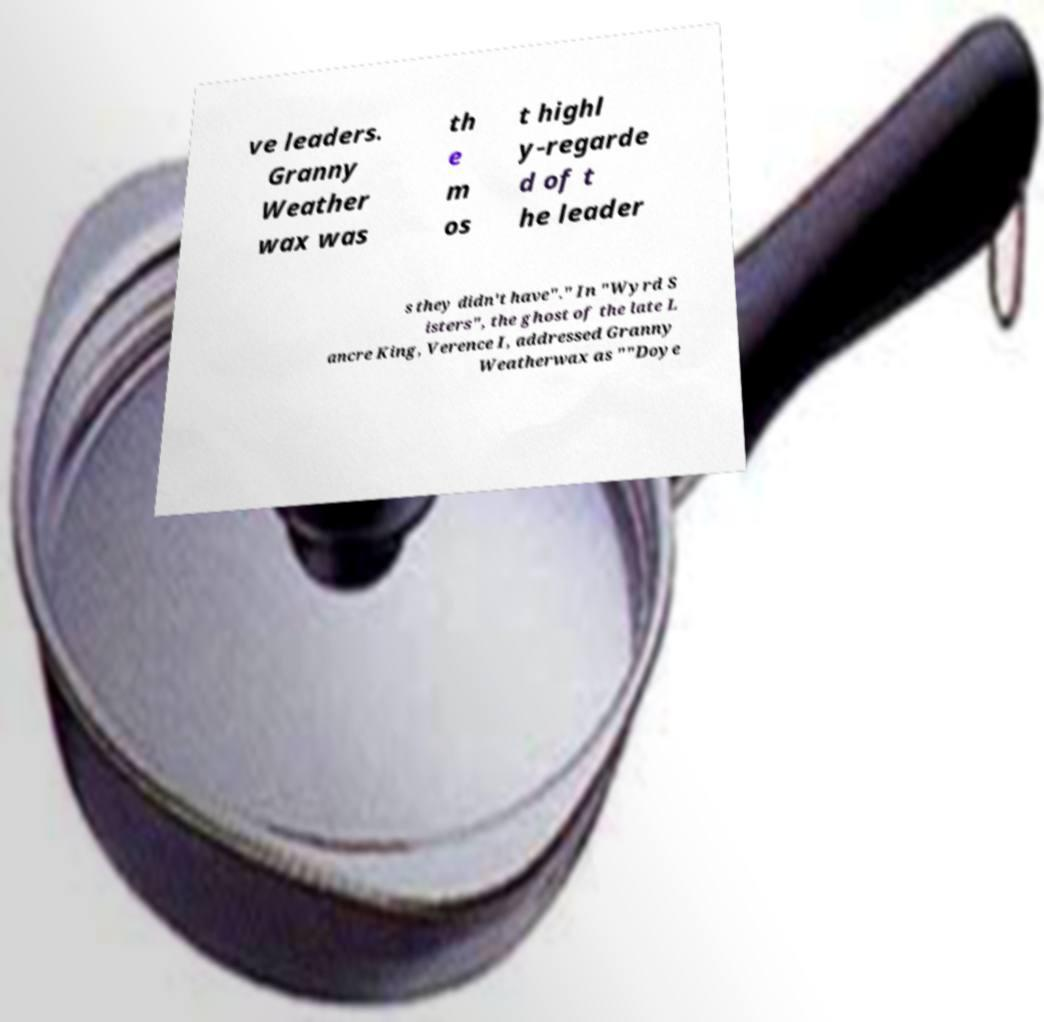Can you accurately transcribe the text from the provided image for me? ve leaders. Granny Weather wax was th e m os t highl y-regarde d of t he leader s they didn't have"." In "Wyrd S isters", the ghost of the late L ancre King, Verence I, addressed Granny Weatherwax as ""Doye 